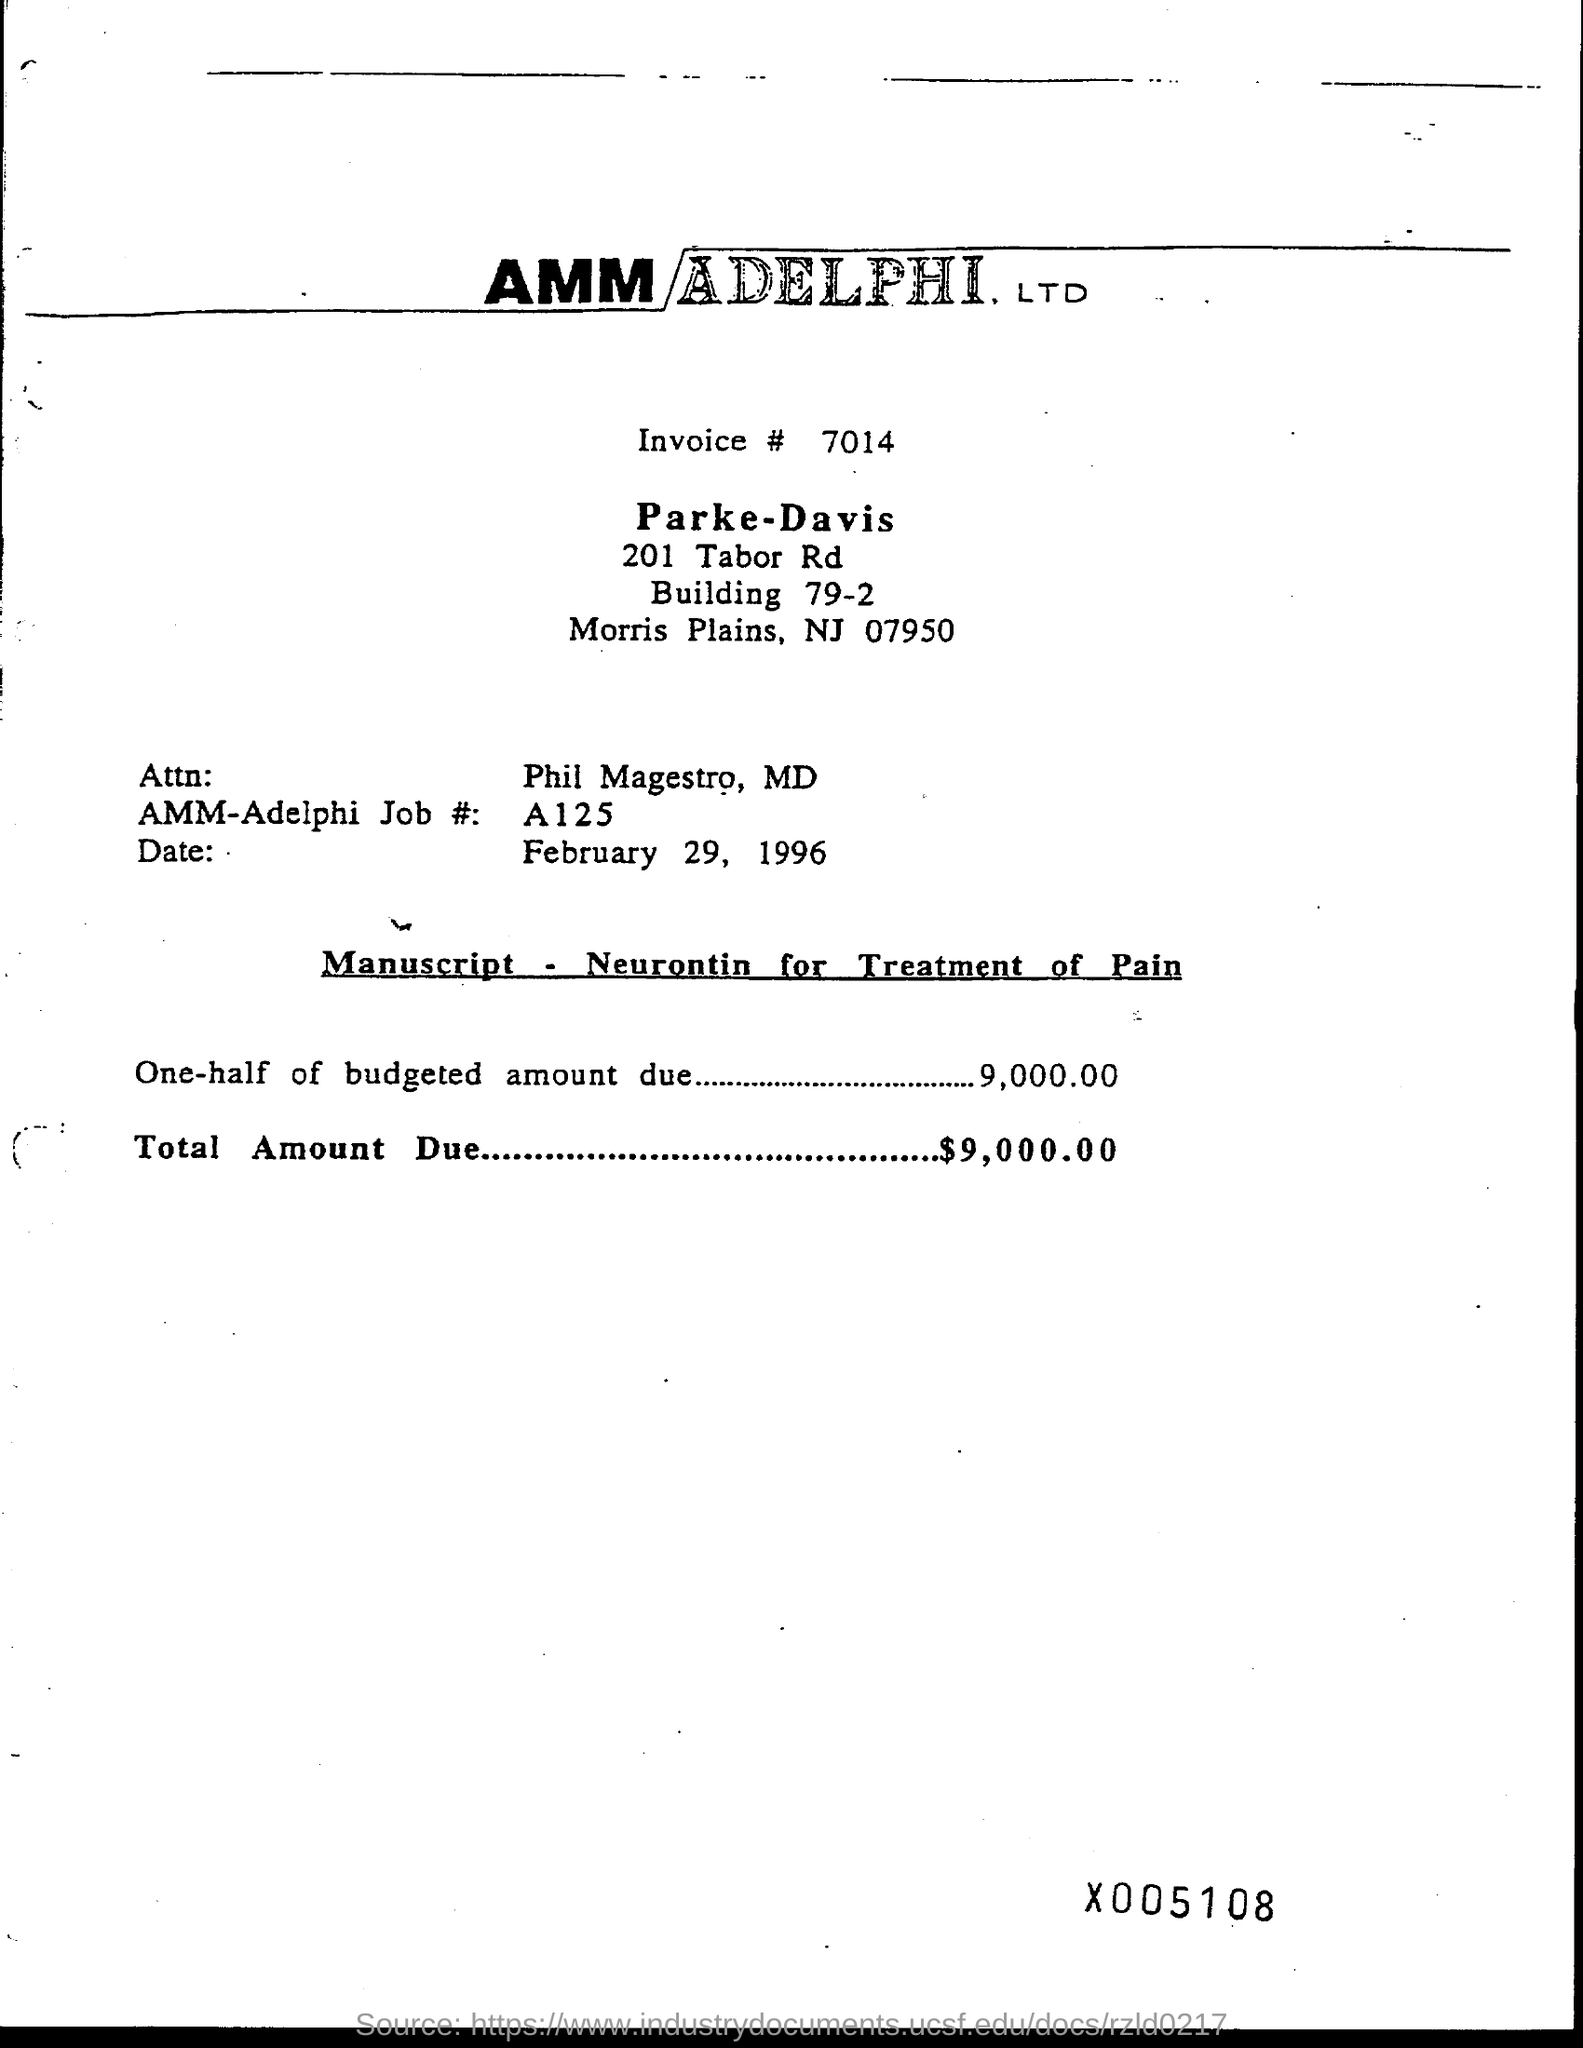What is the invoice # ?
Your response must be concise. 7014. What is the total amount due ?
Your answer should be compact. $9,000.00. What is the date mentioned above manuscript?
Ensure brevity in your answer.  February 29, 1996. What is the name of attn ?
Offer a very short reply. Phil Magestro, MD. 